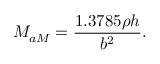<formula> <loc_0><loc_0><loc_500><loc_500>M _ { a M } = \frac { 1 . 3 7 8 5 \rho h } { b ^ { 2 } } .</formula> 